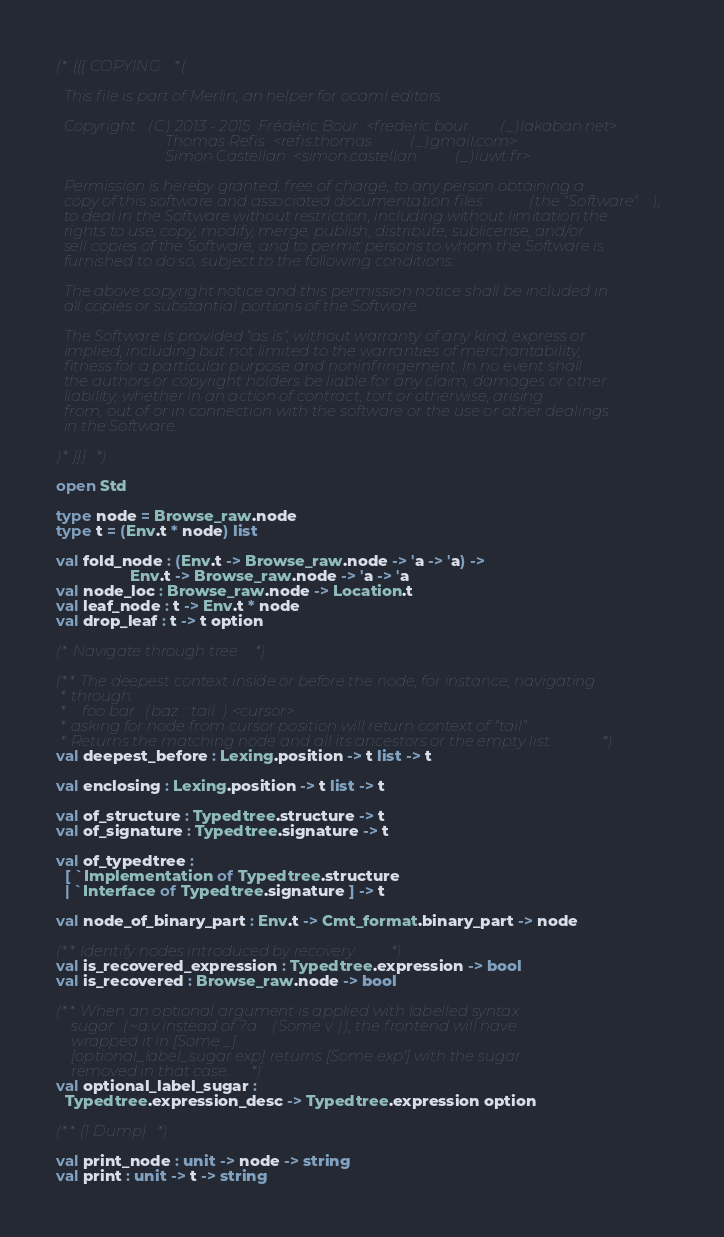<code> <loc_0><loc_0><loc_500><loc_500><_OCaml_>(* {{{ COPYING *(

  This file is part of Merlin, an helper for ocaml editors

  Copyright (C) 2013 - 2015  Frédéric Bour  <frederic.bour(_)lakaban.net>
                             Thomas Refis  <refis.thomas(_)gmail.com>
                             Simon Castellan  <simon.castellan(_)iuwt.fr>

  Permission is hereby granted, free of charge, to any person obtaining a
  copy of this software and associated documentation files (the "Software"),
  to deal in the Software without restriction, including without limitation the
  rights to use, copy, modify, merge, publish, distribute, sublicense, and/or
  sell copies of the Software, and to permit persons to whom the Software is
  furnished to do so, subject to the following conditions:

  The above copyright notice and this permission notice shall be included in
  all copies or substantial portions of the Software.

  The Software is provided "as is", without warranty of any kind, express or
  implied, including but not limited to the warranties of merchantability,
  fitness for a particular purpose and noninfringement. In no event shall
  the authors or copyright holders be liable for any claim, damages or other
  liability, whether in an action of contract, tort or otherwise, arising
  from, out of or in connection with the software or the use or other dealings
  in the Software.

)* }}} *)

open Std

type node = Browse_raw.node
type t = (Env.t * node) list

val fold_node : (Env.t -> Browse_raw.node -> 'a -> 'a) ->
                 Env.t -> Browse_raw.node -> 'a -> 'a
val node_loc : Browse_raw.node -> Location.t
val leaf_node : t -> Env.t * node
val drop_leaf : t -> t option

(* Navigate through tree *)

(** The deepest context inside or before the node, for instance, navigating
 * through:
 *    foo bar (baz :: tail) <cursor>
 * asking for node from cursor position will return context of "tail".
 * Returns the matching node and all its ancestors or the empty list. *)
val deepest_before : Lexing.position -> t list -> t

val enclosing : Lexing.position -> t list -> t

val of_structure : Typedtree.structure -> t
val of_signature : Typedtree.signature -> t

val of_typedtree :
  [ `Implementation of Typedtree.structure
  | `Interface of Typedtree.signature ] -> t

val node_of_binary_part : Env.t -> Cmt_format.binary_part -> node

(** Identify nodes introduced by recovery *)
val is_recovered_expression : Typedtree.expression -> bool
val is_recovered : Browse_raw.node -> bool

(** When an optional argument is applied with labelled syntax
    sugar (~a:v instead of ?a:(Some v)), the frontend will have
    wrapped it in [Some _].
    [optional_label_sugar exp] returns [Some exp'] with the sugar
    removed in that case. *)
val optional_label_sugar :
  Typedtree.expression_desc -> Typedtree.expression option

(** {1 Dump} *)

val print_node : unit -> node -> string
val print : unit -> t -> string
</code> 